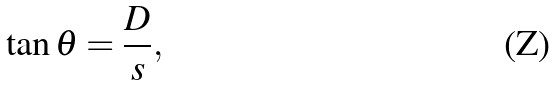Convert formula to latex. <formula><loc_0><loc_0><loc_500><loc_500>\tan \theta = \frac { D } { s } ,</formula> 